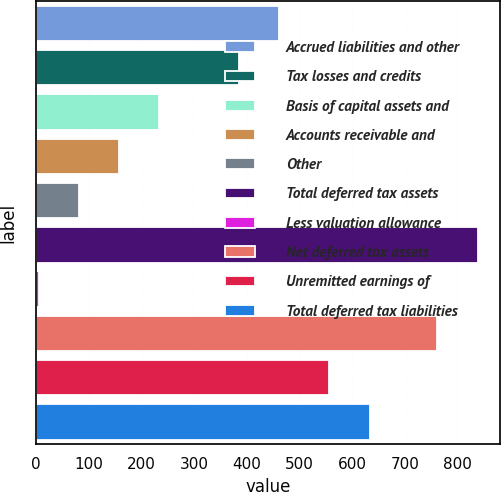Convert chart to OTSL. <chart><loc_0><loc_0><loc_500><loc_500><bar_chart><fcel>Accrued liabilities and other<fcel>Tax losses and credits<fcel>Basis of capital assets and<fcel>Accounts receivable and<fcel>Other<fcel>Total deferred tax assets<fcel>Less valuation allowance<fcel>Net deferred tax assets<fcel>Unremitted earnings of<fcel>Total deferred tax liabilities<nl><fcel>462.2<fcel>386<fcel>233.6<fcel>157.4<fcel>81.2<fcel>838.2<fcel>5<fcel>762<fcel>557<fcel>633.2<nl></chart> 